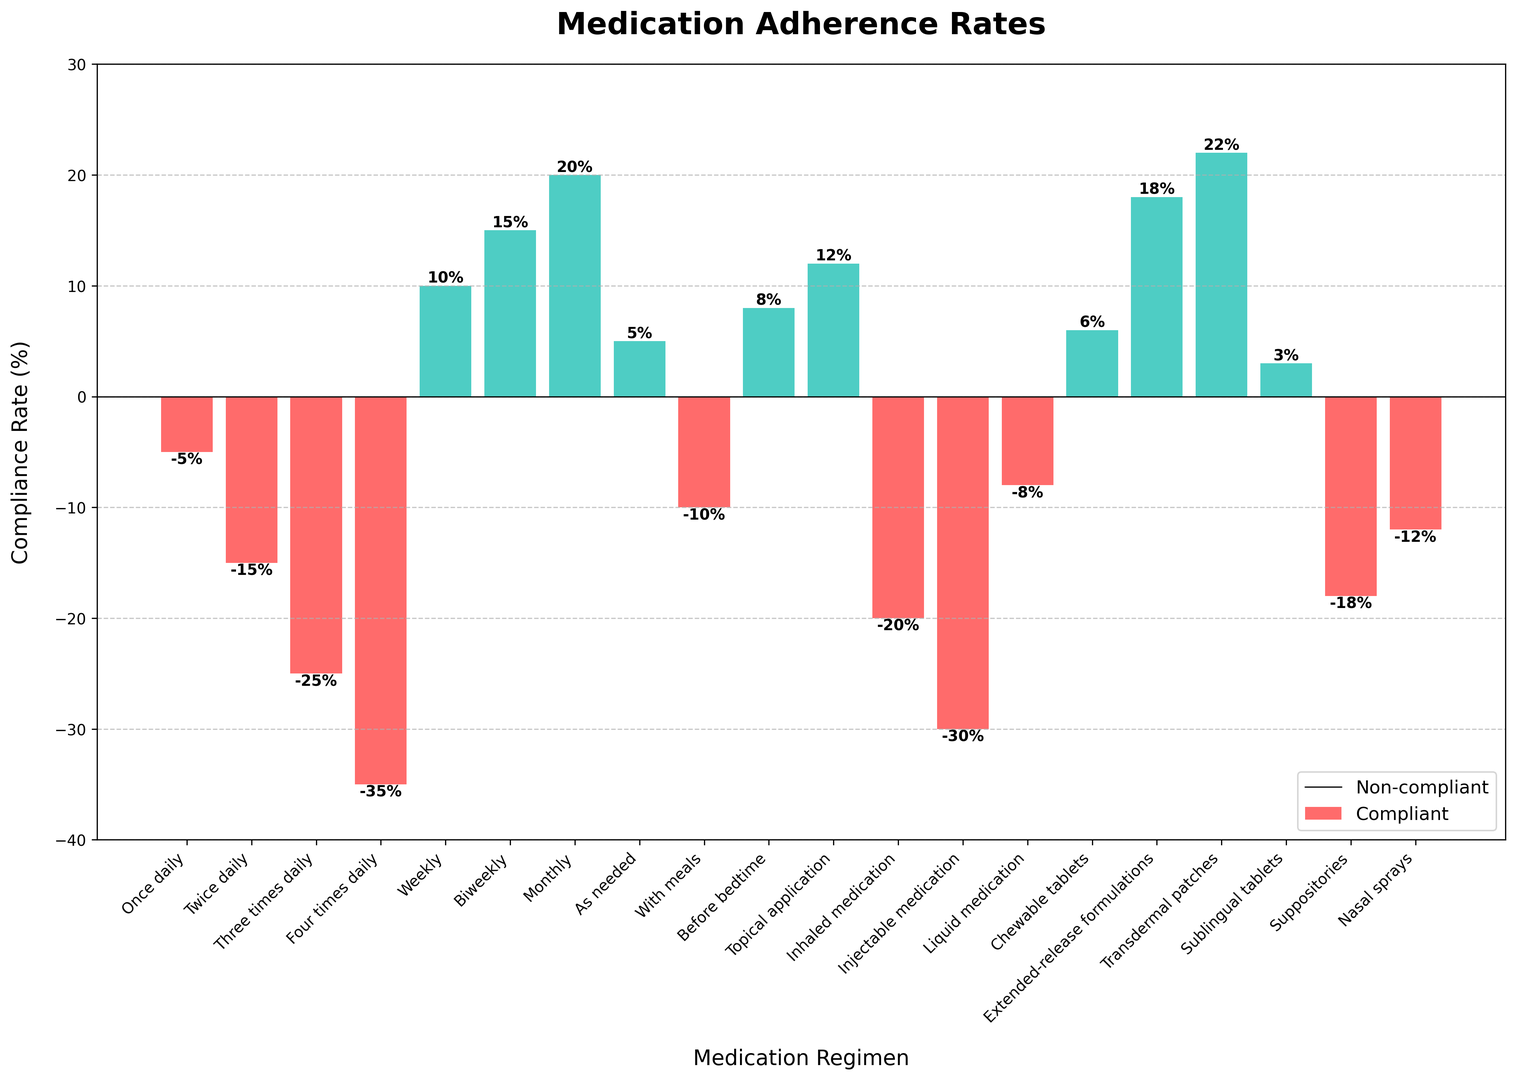What's the medication regimen with the highest compliance rate? To find the highest compliance rate, look for the tallest green bar. The tallest green bar belongs to "Transdermal patches" with a compliance rate of 22%.
Answer: Transdermal patches Which medication regimen shows the least compliance? To determine the least compliance, find the shortest red bar. The shortest red bar is for "Four times daily," which has a compliance rate of -35%.
Answer: Four times daily What is the difference between the compliance rates of "Weekly" and "Injectable medication"? First, find the compliance rates for "Weekly" and "Injectable medication," which are 10% and -30%, respectively. The difference is 10 - (-30) = 10 + 30 = 40.
Answer: 40 Which medication regimens have positive compliance rates? Look for the green bars, which indicate positive compliance rates. The regimens are "Weekly," "Biweekly," "Monthly," "As needed," "Before bedtime," "Topical application," "Chewable tablets," "Extended-release formulations," and "Transdermal patches," and "Sublingual tablets."
Answer: Weekly, Biweekly, Monthly, As needed, Before bedtime, Topical application, Chewable tablets, Extended-release formulations, Transdermal patches, Sublingual tablets What is the average compliance rate for "Once daily," "Twice daily," and "Three times daily"? Find the compliance rates for "Once daily" (-5%), "Twice daily" (-15%), and "Three times daily" (-25%). The sum is -5 + (-15) + (-25) = -45. Divide by 3 to get the average: -45 / 3 = -15.
Answer: -15 Which medication regimen has a compliance rate close to 0%? Identify the bar whose height is closest to the x-axis (0%). "Once daily" has a compliance rate of -5%, which is closest to 0%.
Answer: Once daily How many medication regimens have compliance rates below -20%? Count the bars below -20%: "Three times daily" (-25%), "Four times daily" (-35%), "Injectable medication" (-30%), "Inhaled medication" (-20%), "Suppositories" (-18%), and "Nasal sprays" (-12%). There are 3 medication regimens with compliance below -20%.
Answer: 3 What is the total compliance rate for all regimens with negative rates? Sum the negative compliance rates: -5 + (-15) + (-25) + (-35) + (-10) + (-20) + (-30) + (-8) + (-18) + (-12) = -178.
Answer: -178 